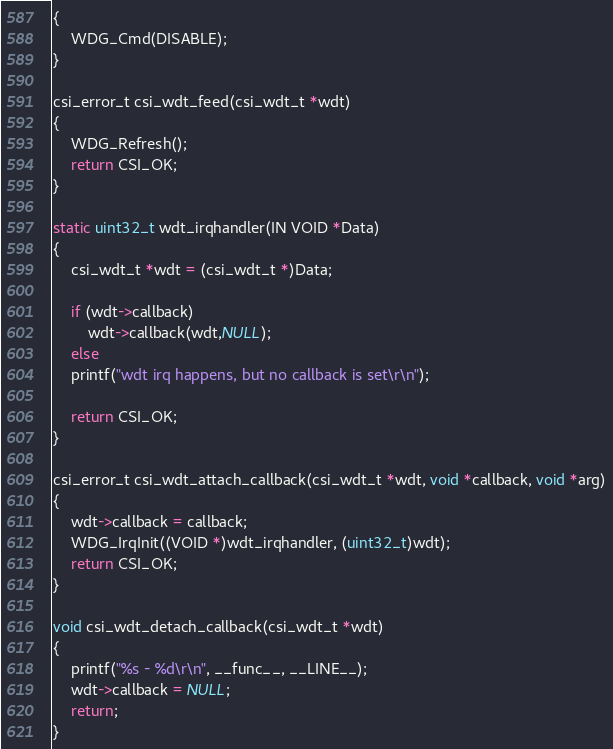Convert code to text. <code><loc_0><loc_0><loc_500><loc_500><_C_>{
    WDG_Cmd(DISABLE);
}

csi_error_t csi_wdt_feed(csi_wdt_t *wdt)
{
    WDG_Refresh();
    return CSI_OK;
}

static uint32_t wdt_irqhandler(IN VOID *Data)
{
    csi_wdt_t *wdt = (csi_wdt_t *)Data;

    if (wdt->callback)
    	wdt->callback(wdt,NULL);
    else
	printf("wdt irq happens, but no callback is set\r\n");

    return CSI_OK;
}

csi_error_t csi_wdt_attach_callback(csi_wdt_t *wdt, void *callback, void *arg)
{
    wdt->callback = callback;
    WDG_IrqInit((VOID *)wdt_irqhandler, (uint32_t)wdt);
    return CSI_OK;
}

void csi_wdt_detach_callback(csi_wdt_t *wdt)
{
    printf("%s - %d\r\n", __func__, __LINE__);
    wdt->callback = NULL;
    return;
}
</code> 